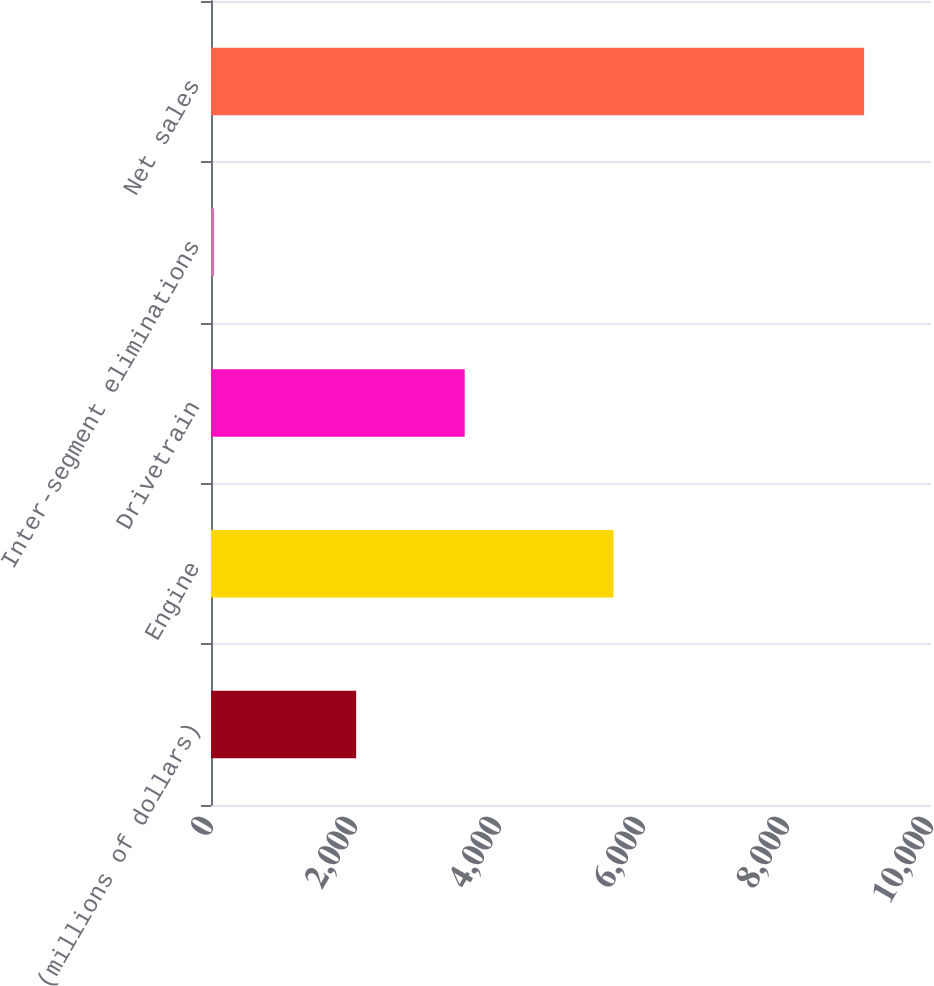<chart> <loc_0><loc_0><loc_500><loc_500><bar_chart><fcel>(millions of dollars)<fcel>Engine<fcel>Drivetrain<fcel>Inter-segment eliminations<fcel>Net sales<nl><fcel>2016<fcel>5590.1<fcel>3523.7<fcel>42.8<fcel>9071<nl></chart> 